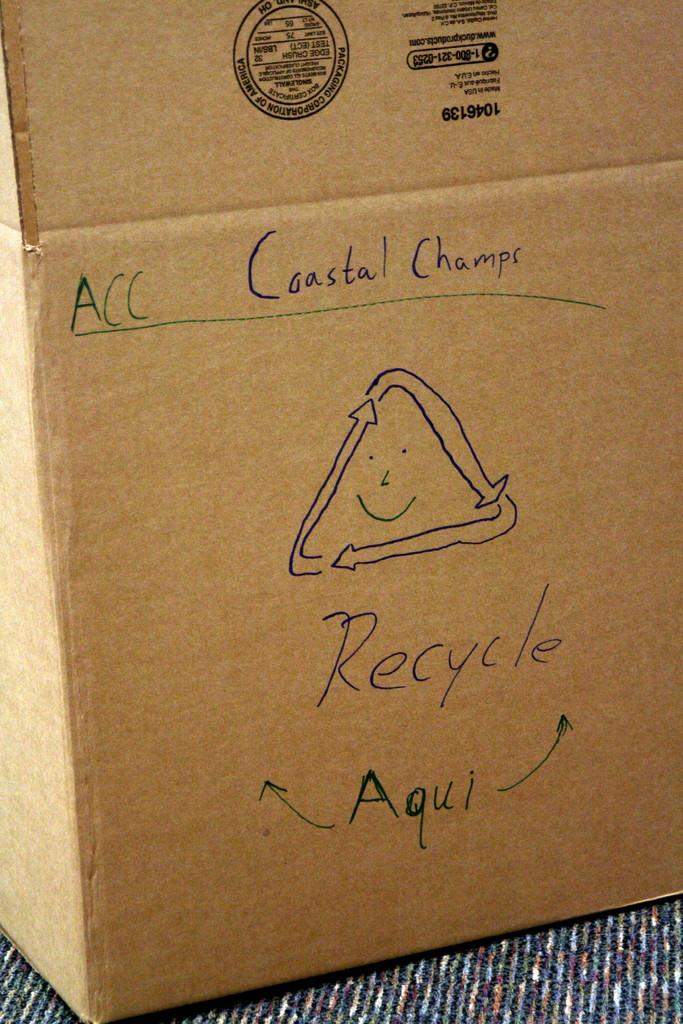<image>
Create a compact narrative representing the image presented. Carboard box that says Coastal Champs and is used for recycling. 